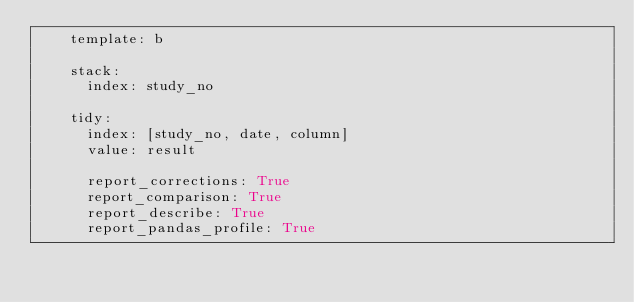Convert code to text. <code><loc_0><loc_0><loc_500><loc_500><_YAML_>    template: b

    stack:
      index: study_no

    tidy:
      index: [study_no, date, column]
      value: result

      report_corrections: True
      report_comparison: True
      report_describe: True
      report_pandas_profile: True</code> 